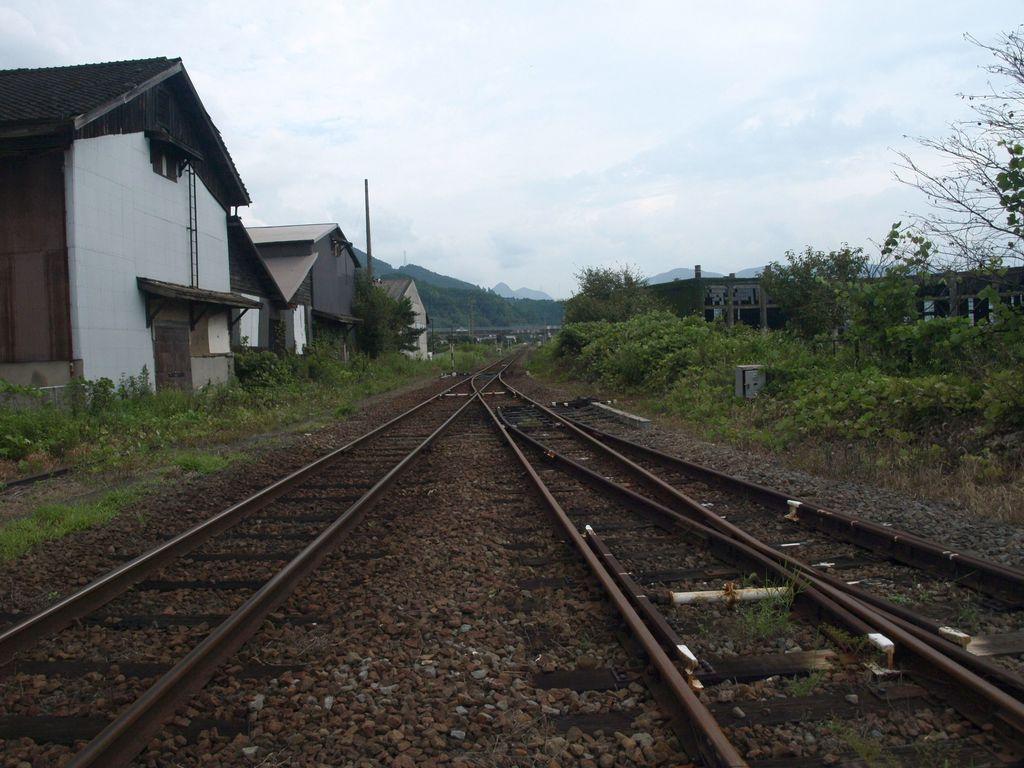Can you describe this image briefly? In this picture we can see few tracks and stones, and we can find few plants, buildings, trees and hills. 